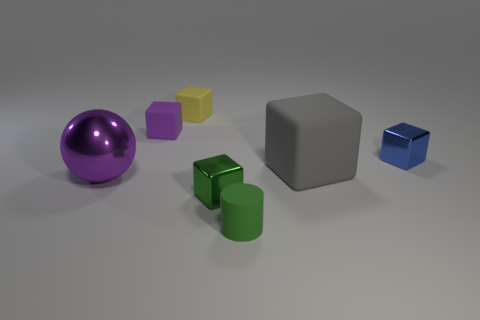Subtract 1 cubes. How many cubes are left? 4 Subtract all green blocks. How many blocks are left? 4 Subtract all purple blocks. How many blocks are left? 4 Subtract all cyan cubes. Subtract all cyan balls. How many cubes are left? 5 Add 3 blue things. How many objects exist? 10 Subtract all cylinders. How many objects are left? 6 Add 4 gray blocks. How many gray blocks exist? 5 Subtract 0 yellow cylinders. How many objects are left? 7 Subtract all gray objects. Subtract all rubber cubes. How many objects are left? 3 Add 7 green objects. How many green objects are left? 9 